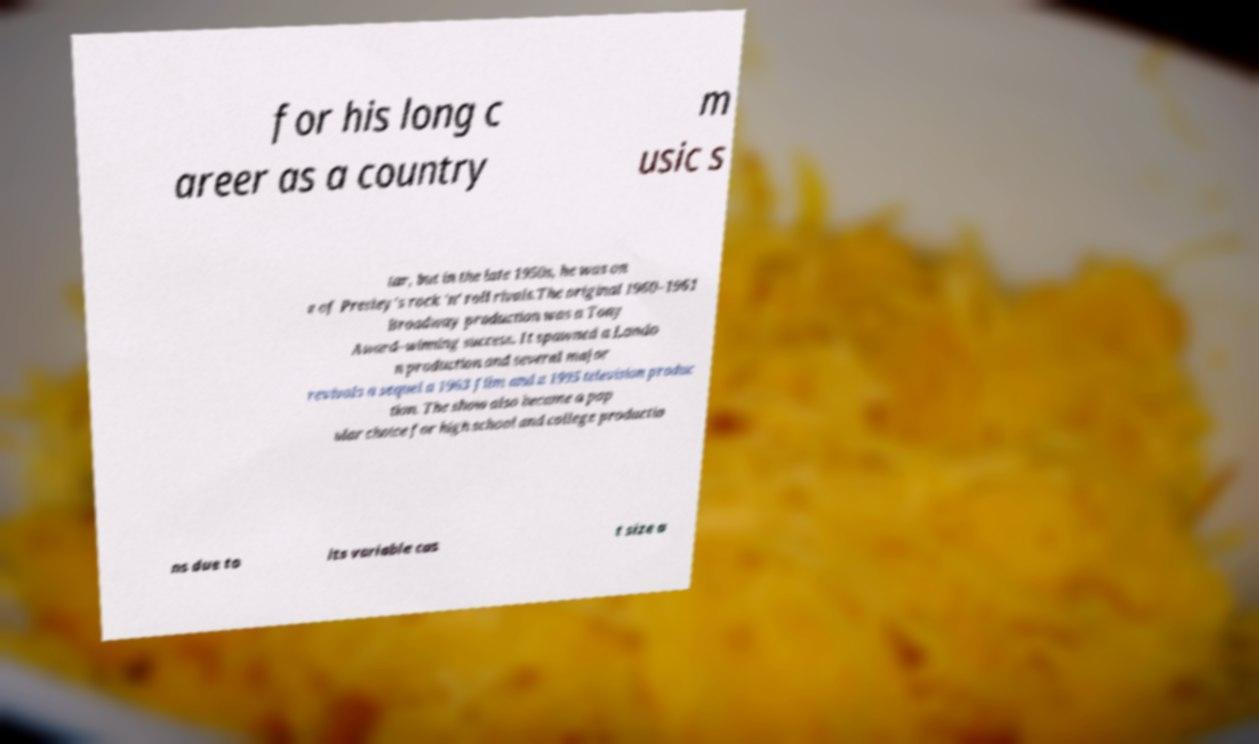Can you accurately transcribe the text from the provided image for me? for his long c areer as a country m usic s tar, but in the late 1950s, he was on e of Presley's rock 'n' roll rivals.The original 1960–1961 Broadway production was a Tony Award–winning success. It spawned a Londo n production and several major revivals a sequel a 1963 film and a 1995 television produc tion. The show also became a pop ular choice for high school and college productio ns due to its variable cas t size a 